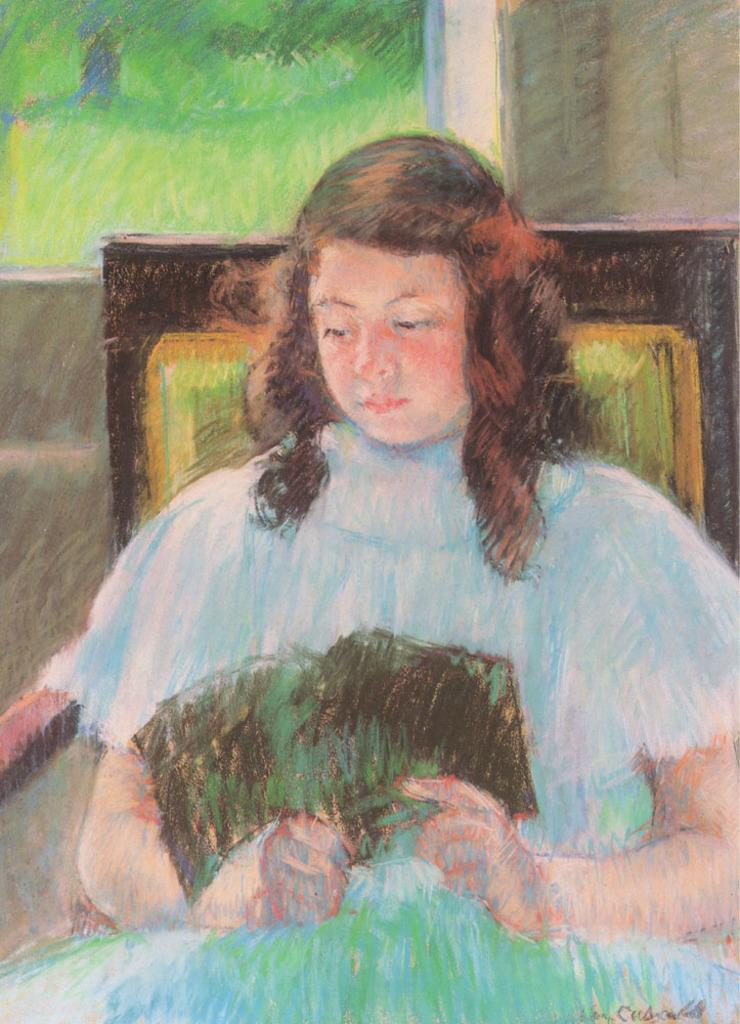What is depicted in the image? The image contains a painting of a lady. What is the lady in the painting doing? The lady in the painting is sitting on a chair and reading a book. What type of flower is the lady holding in the painting? There is no flower present in the painting; the lady is reading a book. 